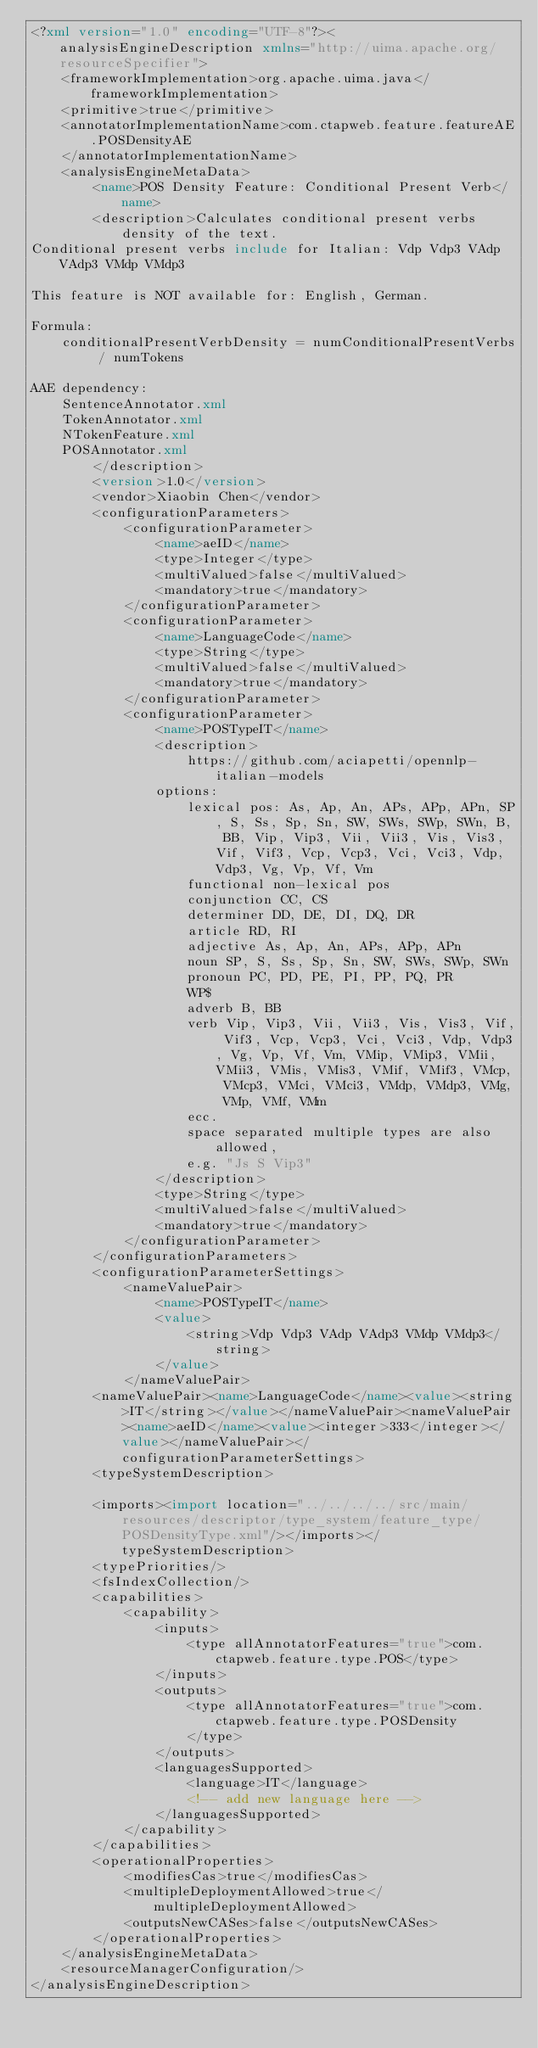<code> <loc_0><loc_0><loc_500><loc_500><_XML_><?xml version="1.0" encoding="UTF-8"?><analysisEngineDescription xmlns="http://uima.apache.org/resourceSpecifier">
	<frameworkImplementation>org.apache.uima.java</frameworkImplementation>
	<primitive>true</primitive>
	<annotatorImplementationName>com.ctapweb.feature.featureAE.POSDensityAE
	</annotatorImplementationName>
	<analysisEngineMetaData>
		<name>POS Density Feature: Conditional Present Verb</name>
		<description>Calculates conditional present verbs density of the text.
Conditional present verbs include for Italian: Vdp Vdp3 VAdp VAdp3 VMdp VMdp3
	
This feature is NOT available for: English, German.
	
Formula:
	conditionalPresentVerbDensity = numConditionalPresentVerbs / numTokens

AAE dependency:
	SentenceAnnotator.xml
	TokenAnnotator.xml
	NTokenFeature.xml
	POSAnnotator.xml
		</description>
		<version>1.0</version>
		<vendor>Xiaobin Chen</vendor>
		<configurationParameters>
			<configurationParameter>
				<name>aeID</name>
				<type>Integer</type>
				<multiValued>false</multiValued>
				<mandatory>true</mandatory>
			</configurationParameter>
			<configurationParameter>
				<name>LanguageCode</name>
				<type>String</type>
				<multiValued>false</multiValued>
				<mandatory>true</mandatory>
			</configurationParameter>
			<configurationParameter>
				<name>POSTypeIT</name>
				<description>
					https://github.com/aciapetti/opennlp-italian-models
				options:
					lexical pos: As, Ap, An, APs, APp, APn, SP, S, Ss, Sp, Sn, SW, SWs, SWp, SWn, B, BB, Vip, Vip3, Vii, Vii3, Vis, Vis3, Vif, Vif3, Vcp, Vcp3, Vci, Vci3, Vdp, Vdp3, Vg, Vp, Vf, Vm
					functional non-lexical pos
					conjunction CC, CS
					determiner DD, DE, DI, DQ, DR
					article RD, RI
					adjective As, Ap, An, APs, APp, APn
					noun SP, S, Ss, Sp, Sn, SW, SWs, SWp, SWn
					pronoun PC, PD, PE, PI, PP, PQ, PR
					WP$
					adverb B, BB
					verb Vip, Vip3, Vii, Vii3, Vis, Vis3, Vif, Vif3, Vcp, Vcp3, Vci, Vci3, Vdp, Vdp3, Vg, Vp, Vf, Vm, VMip, VMip3, VMii, VMii3, VMis, VMis3, VMif, VMif3, VMcp, VMcp3, VMci, VMci3, VMdp, VMdp3, VMg, VMp, VMf, VMm
					ecc.
					space separated multiple types are also allowed,
					e.g. "Js S Vip3"
				</description>
				<type>String</type>
				<multiValued>false</multiValued>
				<mandatory>true</mandatory>
			</configurationParameter>
		</configurationParameters>
		<configurationParameterSettings>
			<nameValuePair>
				<name>POSTypeIT</name>
				<value>
					<string>Vdp Vdp3 VAdp VAdp3 VMdp VMdp3</string>
				</value>
			</nameValuePair>
		<nameValuePair><name>LanguageCode</name><value><string>IT</string></value></nameValuePair><nameValuePair><name>aeID</name><value><integer>333</integer></value></nameValuePair></configurationParameterSettings>
		<typeSystemDescription>
			
		<imports><import location="../../../../src/main/resources/descriptor/type_system/feature_type/POSDensityType.xml"/></imports></typeSystemDescription>
		<typePriorities/>
		<fsIndexCollection/>
		<capabilities>
			<capability>
				<inputs>
					<type allAnnotatorFeatures="true">com.ctapweb.feature.type.POS</type>
				</inputs>
				<outputs>
					<type allAnnotatorFeatures="true">com.ctapweb.feature.type.POSDensity
					</type>
				</outputs>
				<languagesSupported>
					<language>IT</language>
					<!-- add new language here -->
				</languagesSupported>
			</capability>
		</capabilities>
		<operationalProperties>
			<modifiesCas>true</modifiesCas>
			<multipleDeploymentAllowed>true</multipleDeploymentAllowed>
			<outputsNewCASes>false</outputsNewCASes>
		</operationalProperties>
	</analysisEngineMetaData>
	<resourceManagerConfiguration/>
</analysisEngineDescription></code> 